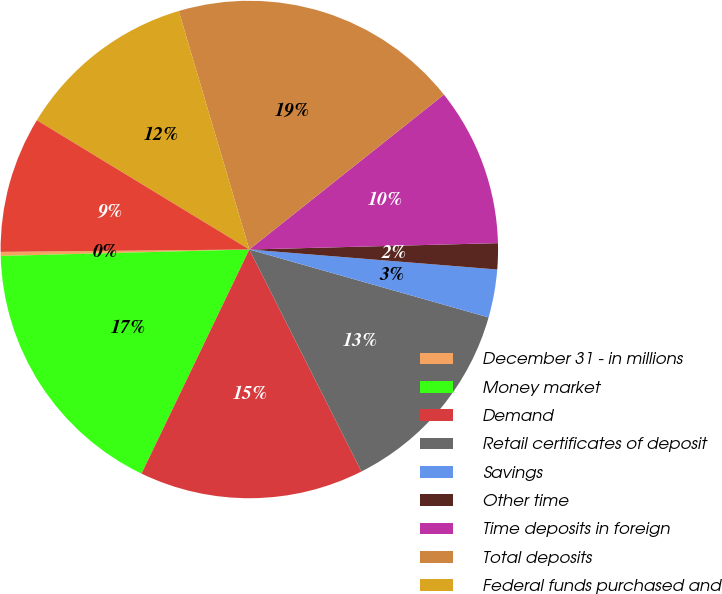Convert chart to OTSL. <chart><loc_0><loc_0><loc_500><loc_500><pie_chart><fcel>December 31 - in millions<fcel>Money market<fcel>Demand<fcel>Retail certificates of deposit<fcel>Savings<fcel>Other time<fcel>Time deposits in foreign<fcel>Total deposits<fcel>Federal funds purchased and<fcel>Federal Home Loan Bank<nl><fcel>0.26%<fcel>17.45%<fcel>14.58%<fcel>13.15%<fcel>3.12%<fcel>1.69%<fcel>10.29%<fcel>18.88%<fcel>11.72%<fcel>8.85%<nl></chart> 